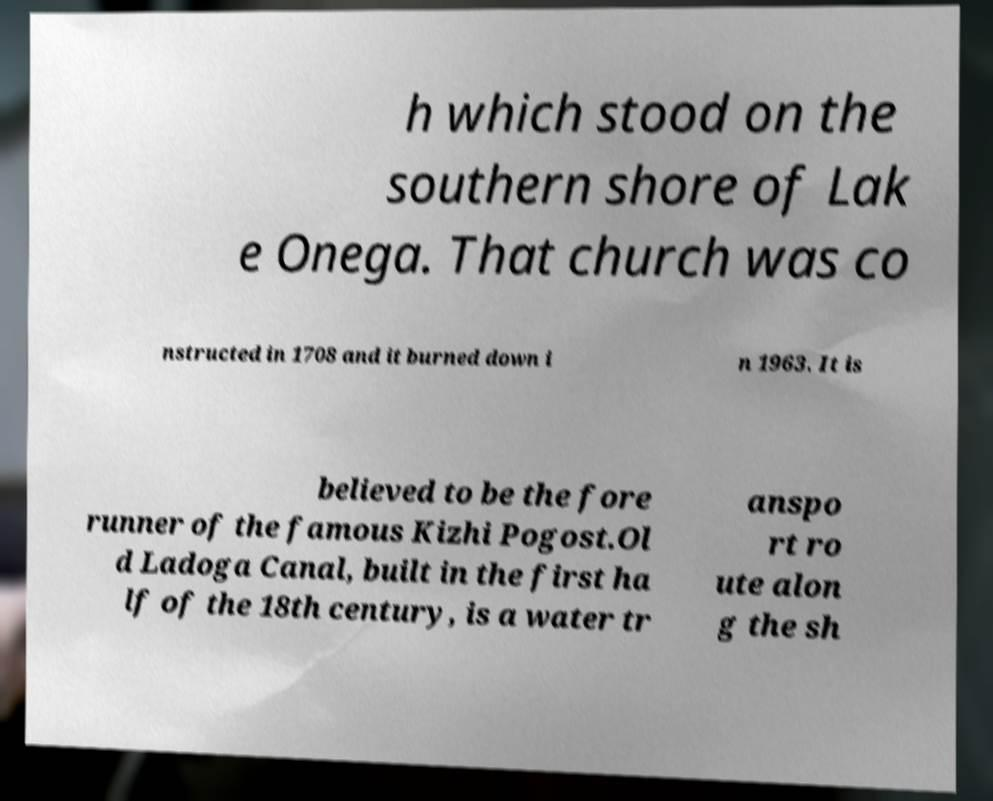Can you accurately transcribe the text from the provided image for me? h which stood on the southern shore of Lak e Onega. That church was co nstructed in 1708 and it burned down i n 1963. It is believed to be the fore runner of the famous Kizhi Pogost.Ol d Ladoga Canal, built in the first ha lf of the 18th century, is a water tr anspo rt ro ute alon g the sh 